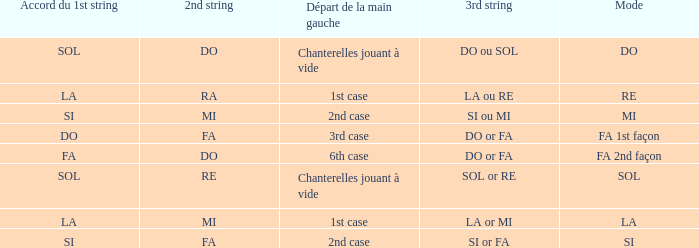For the 2nd string of Do and an Accord du 1st string of FA what is the Depart de la main gauche? 6th case. 